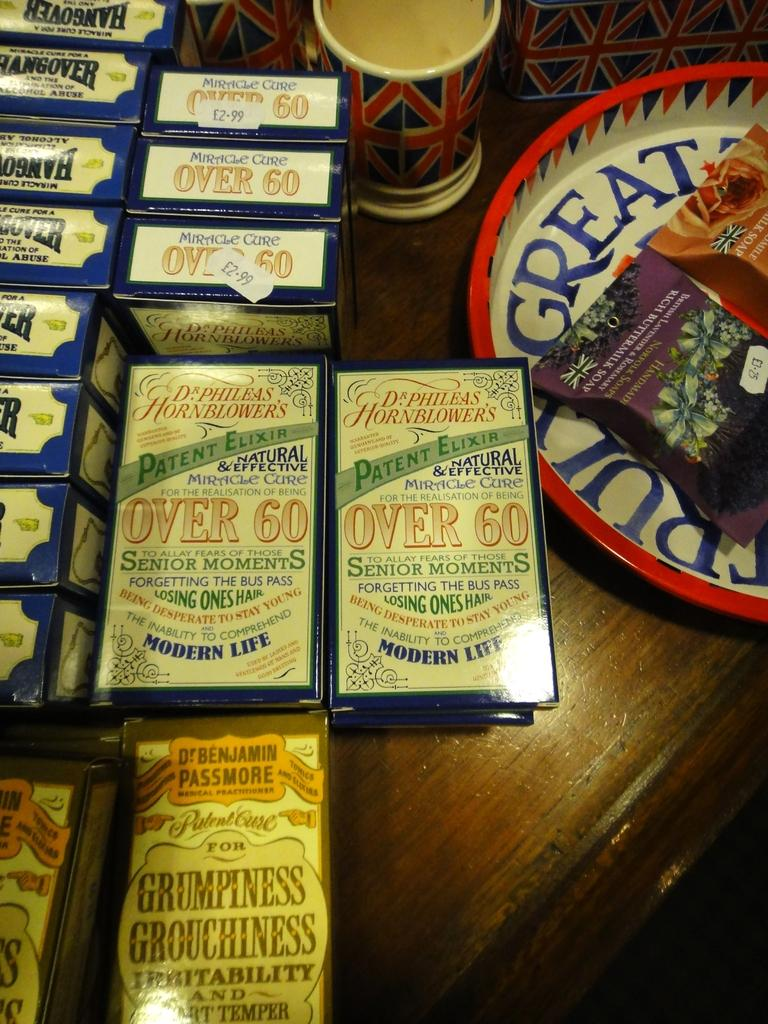<image>
Provide a brief description of the given image. Playing cards are being displayed for senior citizen game night. 